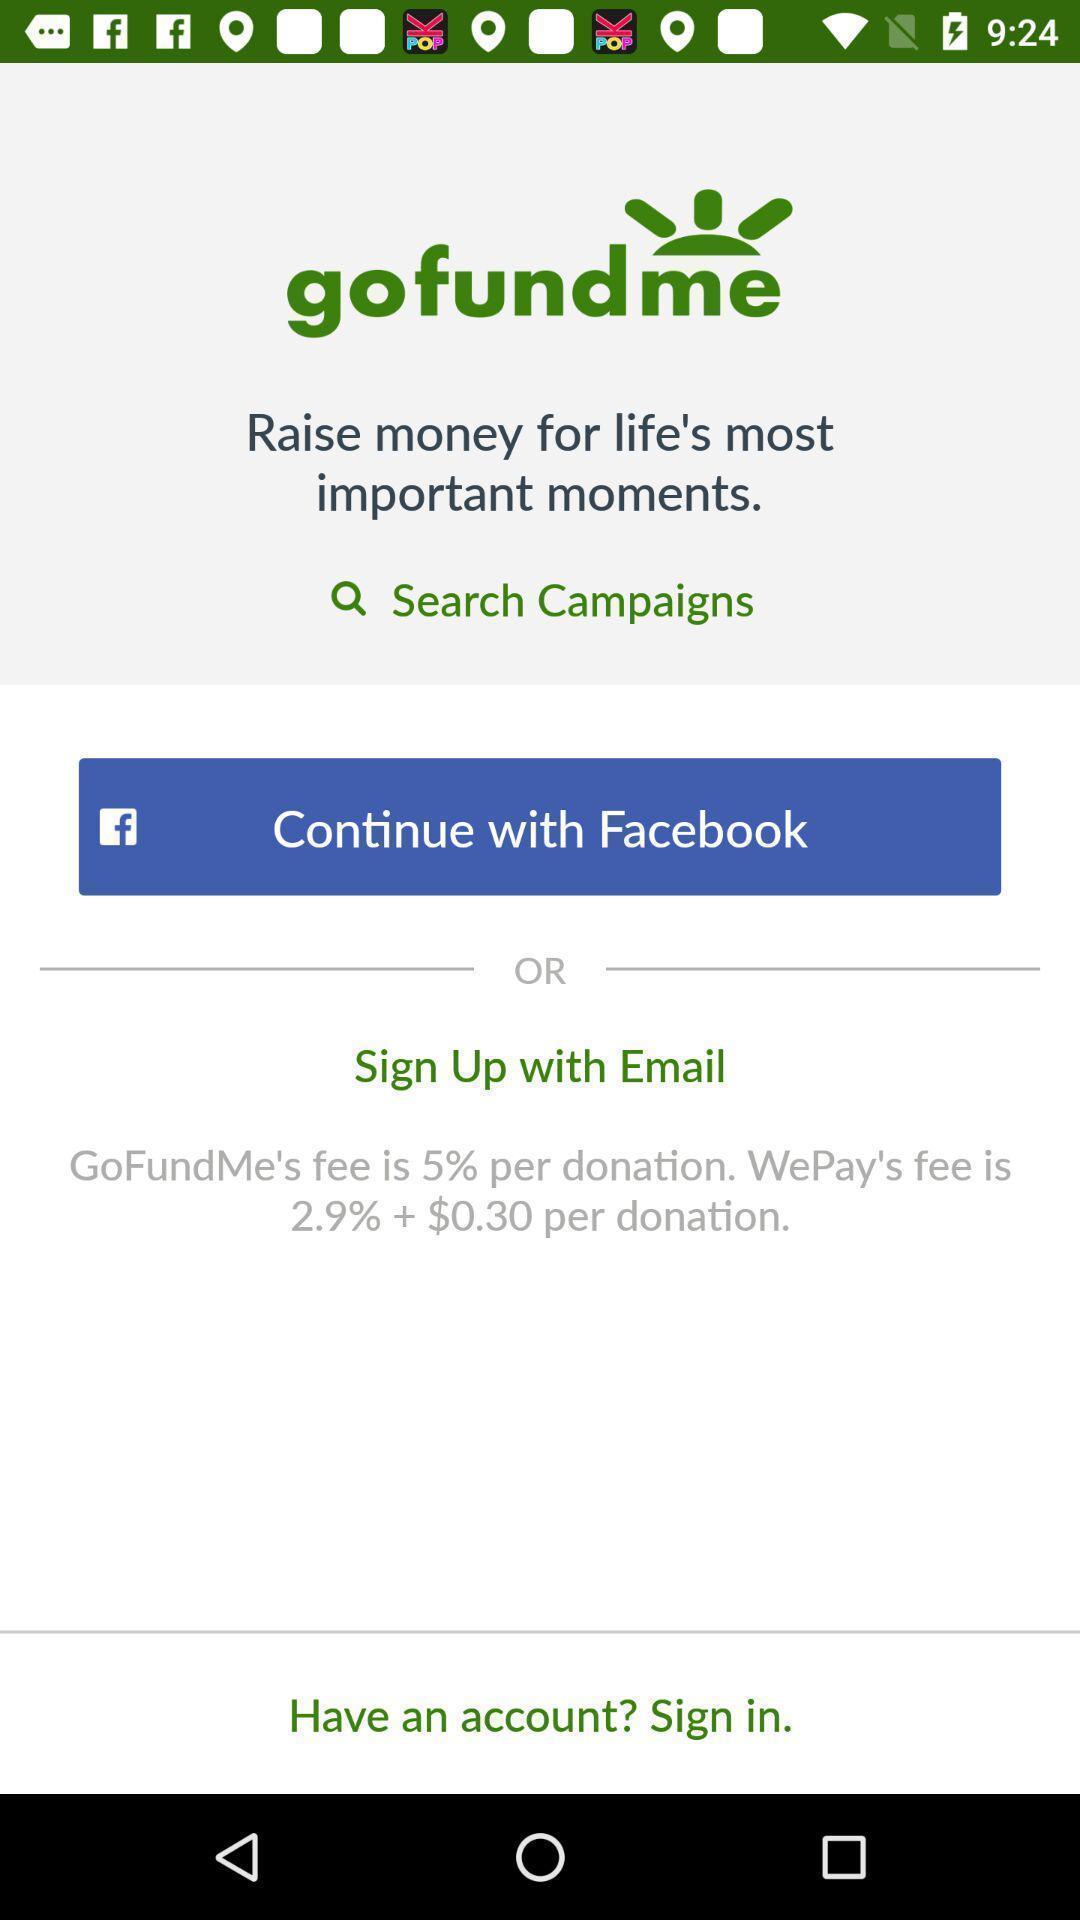What is the overall content of this screenshot? Welcome page for money app. 